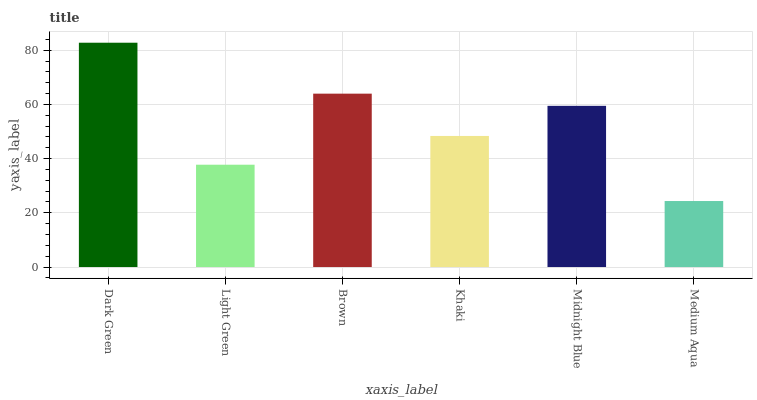Is Medium Aqua the minimum?
Answer yes or no. Yes. Is Dark Green the maximum?
Answer yes or no. Yes. Is Light Green the minimum?
Answer yes or no. No. Is Light Green the maximum?
Answer yes or no. No. Is Dark Green greater than Light Green?
Answer yes or no. Yes. Is Light Green less than Dark Green?
Answer yes or no. Yes. Is Light Green greater than Dark Green?
Answer yes or no. No. Is Dark Green less than Light Green?
Answer yes or no. No. Is Midnight Blue the high median?
Answer yes or no. Yes. Is Khaki the low median?
Answer yes or no. Yes. Is Dark Green the high median?
Answer yes or no. No. Is Medium Aqua the low median?
Answer yes or no. No. 